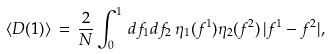Convert formula to latex. <formula><loc_0><loc_0><loc_500><loc_500>\langle D ( 1 ) \rangle \, = \, \frac { 2 } { N } \int _ { 0 } ^ { 1 } \, d f _ { 1 } d f _ { 2 } \, \eta _ { 1 } ( f ^ { 1 } ) \eta _ { 2 } ( f ^ { 2 } ) \, | f ^ { 1 } - f ^ { 2 } | ,</formula> 